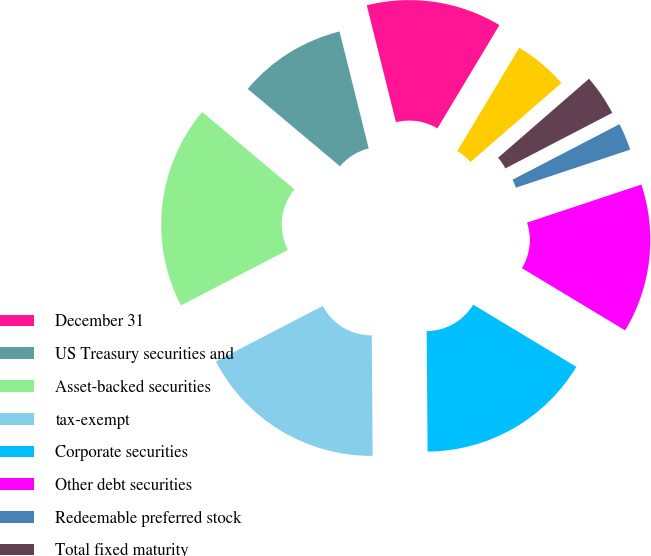Convert chart. <chart><loc_0><loc_0><loc_500><loc_500><pie_chart><fcel>December 31<fcel>US Treasury securities and<fcel>Asset-backed securities<fcel>tax-exempt<fcel>Corporate securities<fcel>Other debt securities<fcel>Redeemable preferred stock<fcel>Total fixed maturity<fcel>Common stock<nl><fcel>12.5%<fcel>10.0%<fcel>18.74%<fcel>17.49%<fcel>16.25%<fcel>13.75%<fcel>2.51%<fcel>3.76%<fcel>5.01%<nl></chart> 